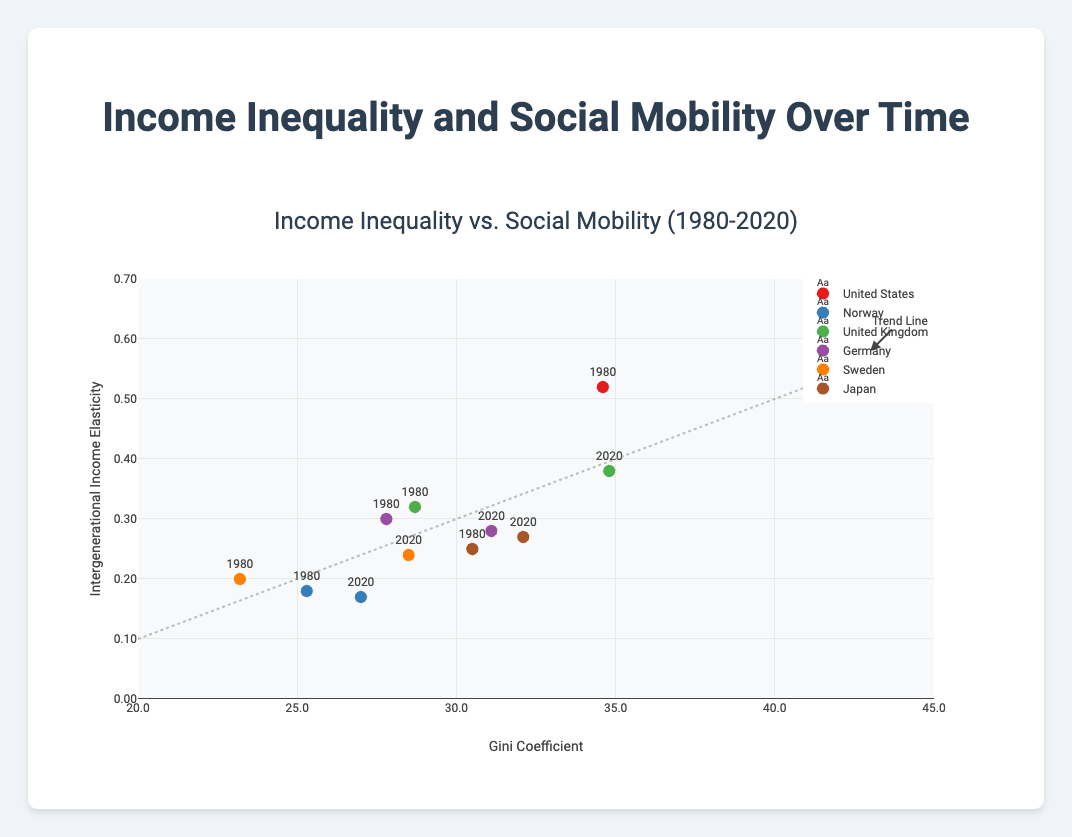What is the title of the figure? The title is located at the top center of the figure and reads "Income Inequality vs. Social Mobility (1980-2020)"
Answer: Income Inequality vs. Social Mobility (1980-2020) What does the X-axis represent? The label on the X-axis reads "Gini Coefficient," which represents the measure of income inequality.
Answer: Gini Coefficient Which country has the highest Gini Coefficient in 2020? By looking at the markers for the year 2020, the United States has the highest Gini Coefficient at 41.5.
Answer: United States What color represents Norway in the scatter plot? Each country is represented by distinct colors. In the figure, Norway is represented by the color blue.
Answer: Blue How do the Gini Coefficients for Germany in 1980 and 2020 compare? Comparing the markers, Germany’s Gini Coefficient increased from 27.8 in 1980 to 31.1 in 2020.
Answer: Increased Which country shows a decrease in intergenerational income elasticity from 1980 to 2020? By examining the data points for changes, Norway shows a decrease in intergenerational income elasticity from 0.18 in 1980 to 0.17 in 2020.
Answer: Norway How does the trend line assist in interpreting the figure? The trend line provides a visual indication of the general relationship between Gini Coefficient and intergenerational income elasticity, suggesting that as Gini Coefficient increases, intergenerational income elasticity also tends to increase.
Answer: Shows relationship Which country has the lowest intergenerational income elasticity in 1980? By looking at the markers for the year 1980, Norway has the lowest intergenerational income elasticity at 0.18.
Answer: Norway What does the annotation "Trend Line" indicate? The annotation "Trend Line" points to the dotted line that suggests the overall trend in the data, emphasizing the relationship between the Gini Coefficient and intergenerational income elasticity.
Answer: Overall trend Is there any country where both the Gini Coefficient and intergenerational income elasticity decreased between 1980 and 2020? Evaluating each country, Norway is the only country where both the Gini Coefficient (25.3 to 27.0) and intergenerational income elasticity (0.18 to 0.17) decreased.
Answer: No 